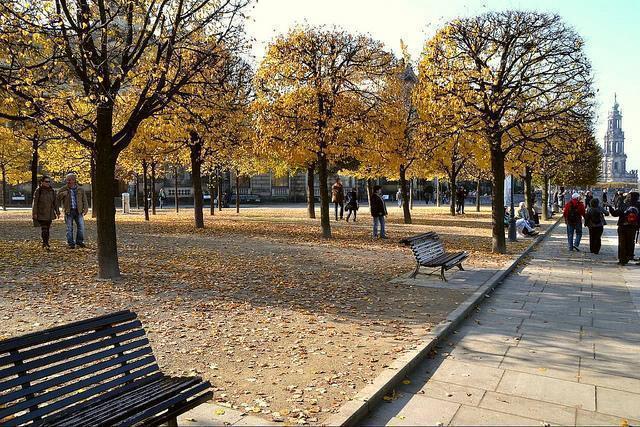How many months till the leaves turn green?
From the following four choices, select the correct answer to address the question.
Options: 3-4, 1-2, 5-7, 10-12. 5-7. 